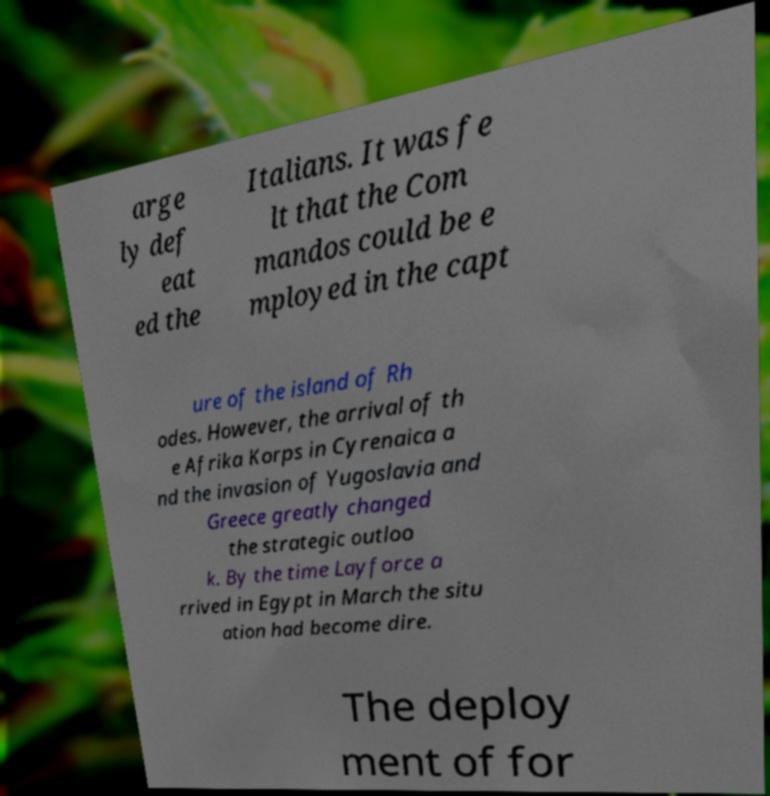Could you extract and type out the text from this image? arge ly def eat ed the Italians. It was fe lt that the Com mandos could be e mployed in the capt ure of the island of Rh odes. However, the arrival of th e Afrika Korps in Cyrenaica a nd the invasion of Yugoslavia and Greece greatly changed the strategic outloo k. By the time Layforce a rrived in Egypt in March the situ ation had become dire. The deploy ment of for 